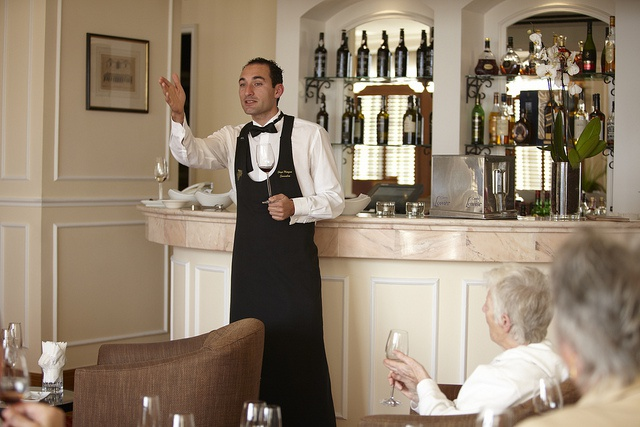Describe the objects in this image and their specific colors. I can see people in gray, black, lightgray, and darkgray tones, couch in gray, brown, maroon, and black tones, chair in gray, brown, maroon, and black tones, people in gray, darkgray, and tan tones, and people in gray, white, and tan tones in this image. 